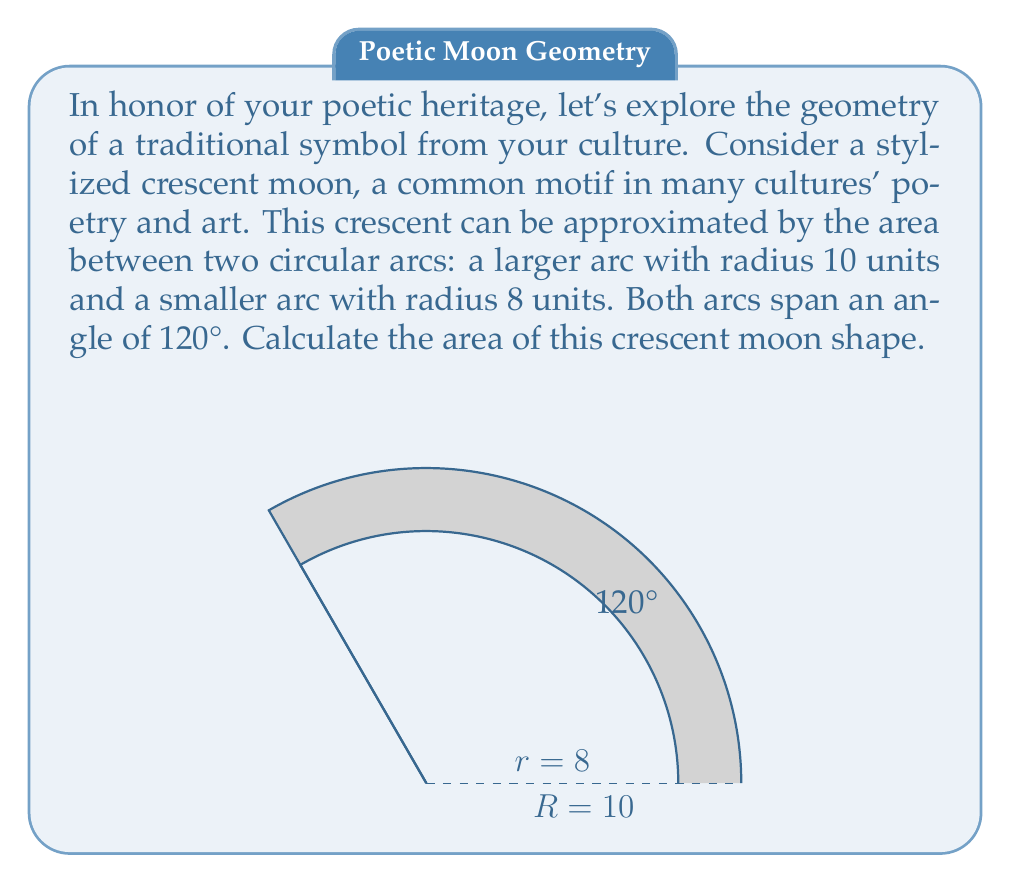Solve this math problem. To solve this problem, we'll follow these steps:

1) The area of the crescent is the difference between the areas of the larger circular sector and the smaller circular sector.

2) The formula for the area of a circular sector is:
   $$A = \frac{1}{2}r^2\theta$$
   where $r$ is the radius and $\theta$ is the angle in radians.

3) We need to convert 120° to radians:
   $$120° = 120 \cdot \frac{\pi}{180} = \frac{2\pi}{3} \text{ radians}$$

4) Now, let's calculate the area of the larger sector:
   $$A_1 = \frac{1}{2} \cdot 10^2 \cdot \frac{2\pi}{3} = \frac{100\pi}{3} \text{ square units}$$

5) Calculate the area of the smaller sector:
   $$A_2 = \frac{1}{2} \cdot 8^2 \cdot \frac{2\pi}{3} = \frac{64\pi}{3} \text{ square units}$$

6) The area of the crescent is the difference:
   $$A_{\text{crescent}} = A_1 - A_2 = \frac{100\pi}{3} - \frac{64\pi}{3} = \frac{36\pi}{3} = 12\pi \text{ square units}$$

Thus, the area of the crescent moon shape is $12\pi$ square units.
Answer: $12\pi$ square units 